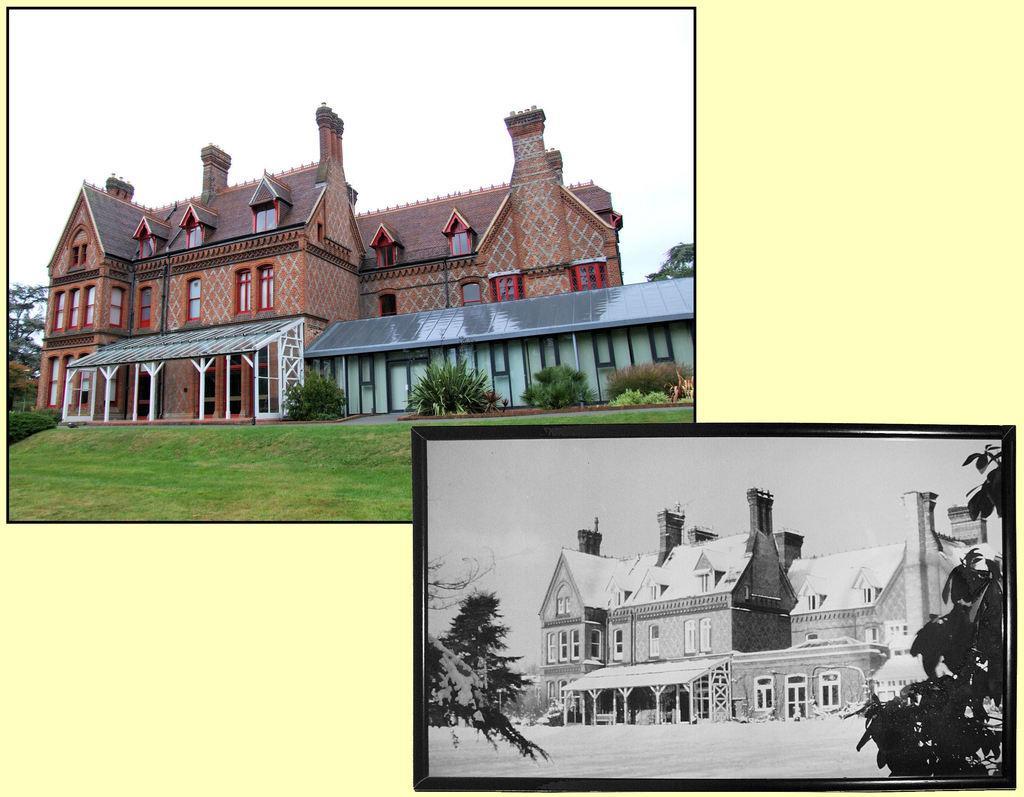Could you give a brief overview of what you see in this image? This is a collage picture. Here we can see buildings, grass, plants, trees, and sky. 